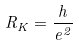Convert formula to latex. <formula><loc_0><loc_0><loc_500><loc_500>R _ { K } = \frac { h } { e ^ { 2 } }</formula> 